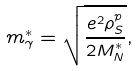Convert formula to latex. <formula><loc_0><loc_0><loc_500><loc_500>m ^ { \ast } _ { \gamma } = \sqrt { \frac { e ^ { 2 } \rho _ { S } ^ { p } } { 2 M ^ { \ast } _ { N } } } ,</formula> 